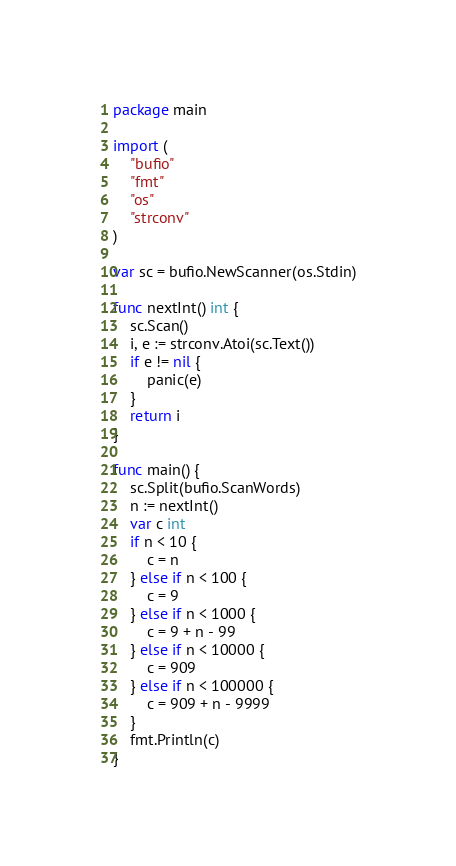Convert code to text. <code><loc_0><loc_0><loc_500><loc_500><_Go_>package main

import (
	"bufio"
	"fmt"
	"os"
	"strconv"
)

var sc = bufio.NewScanner(os.Stdin)

func nextInt() int {
	sc.Scan()
	i, e := strconv.Atoi(sc.Text())
	if e != nil {
		panic(e)
	}
	return i
}

func main() {
	sc.Split(bufio.ScanWords)
	n := nextInt()
	var c int
	if n < 10 {
		c = n
	} else if n < 100 {
		c = 9
	} else if n < 1000 {
		c = 9 + n - 99
	} else if n < 10000 {
		c = 909
	} else if n < 100000 {
		c = 909 + n - 9999
	}
	fmt.Println(c)
}
</code> 